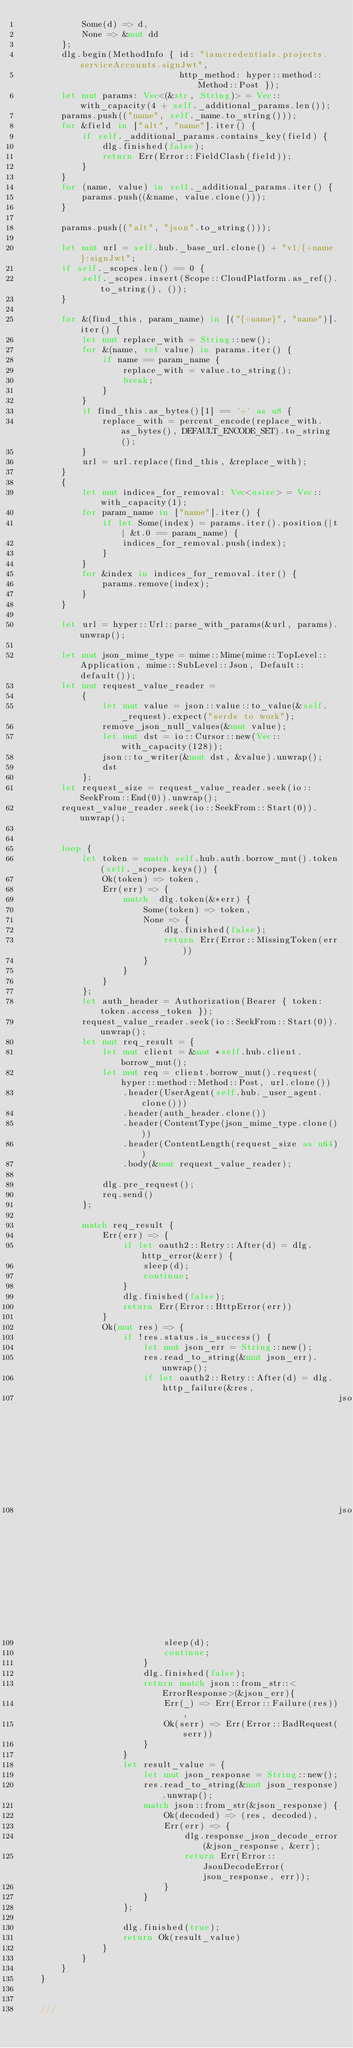<code> <loc_0><loc_0><loc_500><loc_500><_Rust_>            Some(d) => d,
            None => &mut dd
        };
        dlg.begin(MethodInfo { id: "iamcredentials.projects.serviceAccounts.signJwt",
                               http_method: hyper::method::Method::Post });
        let mut params: Vec<(&str, String)> = Vec::with_capacity(4 + self._additional_params.len());
        params.push(("name", self._name.to_string()));
        for &field in ["alt", "name"].iter() {
            if self._additional_params.contains_key(field) {
                dlg.finished(false);
                return Err(Error::FieldClash(field));
            }
        }
        for (name, value) in self._additional_params.iter() {
            params.push((&name, value.clone()));
        }

        params.push(("alt", "json".to_string()));

        let mut url = self.hub._base_url.clone() + "v1/{+name}:signJwt";
        if self._scopes.len() == 0 {
            self._scopes.insert(Scope::CloudPlatform.as_ref().to_string(), ());
        }

        for &(find_this, param_name) in [("{+name}", "name")].iter() {
            let mut replace_with = String::new();
            for &(name, ref value) in params.iter() {
                if name == param_name {
                    replace_with = value.to_string();
                    break;
                }
            }
            if find_this.as_bytes()[1] == '+' as u8 {
                replace_with = percent_encode(replace_with.as_bytes(), DEFAULT_ENCODE_SET).to_string();
            }
            url = url.replace(find_this, &replace_with);
        }
        {
            let mut indices_for_removal: Vec<usize> = Vec::with_capacity(1);
            for param_name in ["name"].iter() {
                if let Some(index) = params.iter().position(|t| &t.0 == param_name) {
                    indices_for_removal.push(index);
                }
            }
            for &index in indices_for_removal.iter() {
                params.remove(index);
            }
        }

        let url = hyper::Url::parse_with_params(&url, params).unwrap();

        let mut json_mime_type = mime::Mime(mime::TopLevel::Application, mime::SubLevel::Json, Default::default());
        let mut request_value_reader =
            {
                let mut value = json::value::to_value(&self._request).expect("serde to work");
                remove_json_null_values(&mut value);
                let mut dst = io::Cursor::new(Vec::with_capacity(128));
                json::to_writer(&mut dst, &value).unwrap();
                dst
            };
        let request_size = request_value_reader.seek(io::SeekFrom::End(0)).unwrap();
        request_value_reader.seek(io::SeekFrom::Start(0)).unwrap();


        loop {
            let token = match self.hub.auth.borrow_mut().token(self._scopes.keys()) {
                Ok(token) => token,
                Err(err) => {
                    match  dlg.token(&*err) {
                        Some(token) => token,
                        None => {
                            dlg.finished(false);
                            return Err(Error::MissingToken(err))
                        }
                    }
                }
            };
            let auth_header = Authorization(Bearer { token: token.access_token });
            request_value_reader.seek(io::SeekFrom::Start(0)).unwrap();
            let mut req_result = {
                let mut client = &mut *self.hub.client.borrow_mut();
                let mut req = client.borrow_mut().request(hyper::method::Method::Post, url.clone())
                    .header(UserAgent(self.hub._user_agent.clone()))
                    .header(auth_header.clone())
                    .header(ContentType(json_mime_type.clone()))
                    .header(ContentLength(request_size as u64))
                    .body(&mut request_value_reader);

                dlg.pre_request();
                req.send()
            };

            match req_result {
                Err(err) => {
                    if let oauth2::Retry::After(d) = dlg.http_error(&err) {
                        sleep(d);
                        continue;
                    }
                    dlg.finished(false);
                    return Err(Error::HttpError(err))
                }
                Ok(mut res) => {
                    if !res.status.is_success() {
                        let mut json_err = String::new();
                        res.read_to_string(&mut json_err).unwrap();
                        if let oauth2::Retry::After(d) = dlg.http_failure(&res,
                                                              json::from_str(&json_err).ok(),
                                                              json::from_str(&json_err).ok()) {
                            sleep(d);
                            continue;
                        }
                        dlg.finished(false);
                        return match json::from_str::<ErrorResponse>(&json_err){
                            Err(_) => Err(Error::Failure(res)),
                            Ok(serr) => Err(Error::BadRequest(serr))
                        }
                    }
                    let result_value = {
                        let mut json_response = String::new();
                        res.read_to_string(&mut json_response).unwrap();
                        match json::from_str(&json_response) {
                            Ok(decoded) => (res, decoded),
                            Err(err) => {
                                dlg.response_json_decode_error(&json_response, &err);
                                return Err(Error::JsonDecodeError(json_response, err));
                            }
                        }
                    };

                    dlg.finished(true);
                    return Ok(result_value)
                }
            }
        }
    }


    ///</code> 